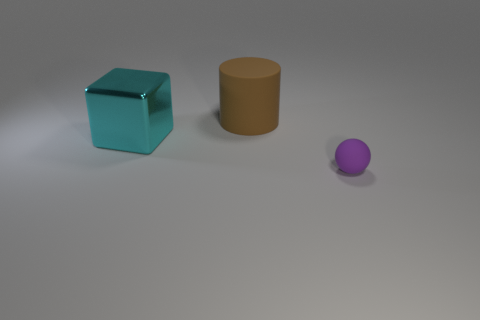Add 1 brown matte objects. How many objects exist? 4 Subtract all balls. How many objects are left? 2 Add 3 cylinders. How many cylinders are left? 4 Add 3 green metal cylinders. How many green metal cylinders exist? 3 Subtract 0 yellow cubes. How many objects are left? 3 Subtract all yellow spheres. Subtract all cyan blocks. How many spheres are left? 1 Subtract all tiny brown metallic blocks. Subtract all small purple rubber things. How many objects are left? 2 